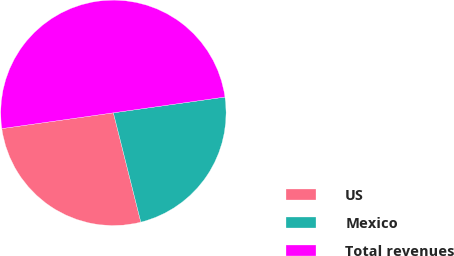<chart> <loc_0><loc_0><loc_500><loc_500><pie_chart><fcel>US<fcel>Mexico<fcel>Total revenues<nl><fcel>26.68%<fcel>23.32%<fcel>50.0%<nl></chart> 